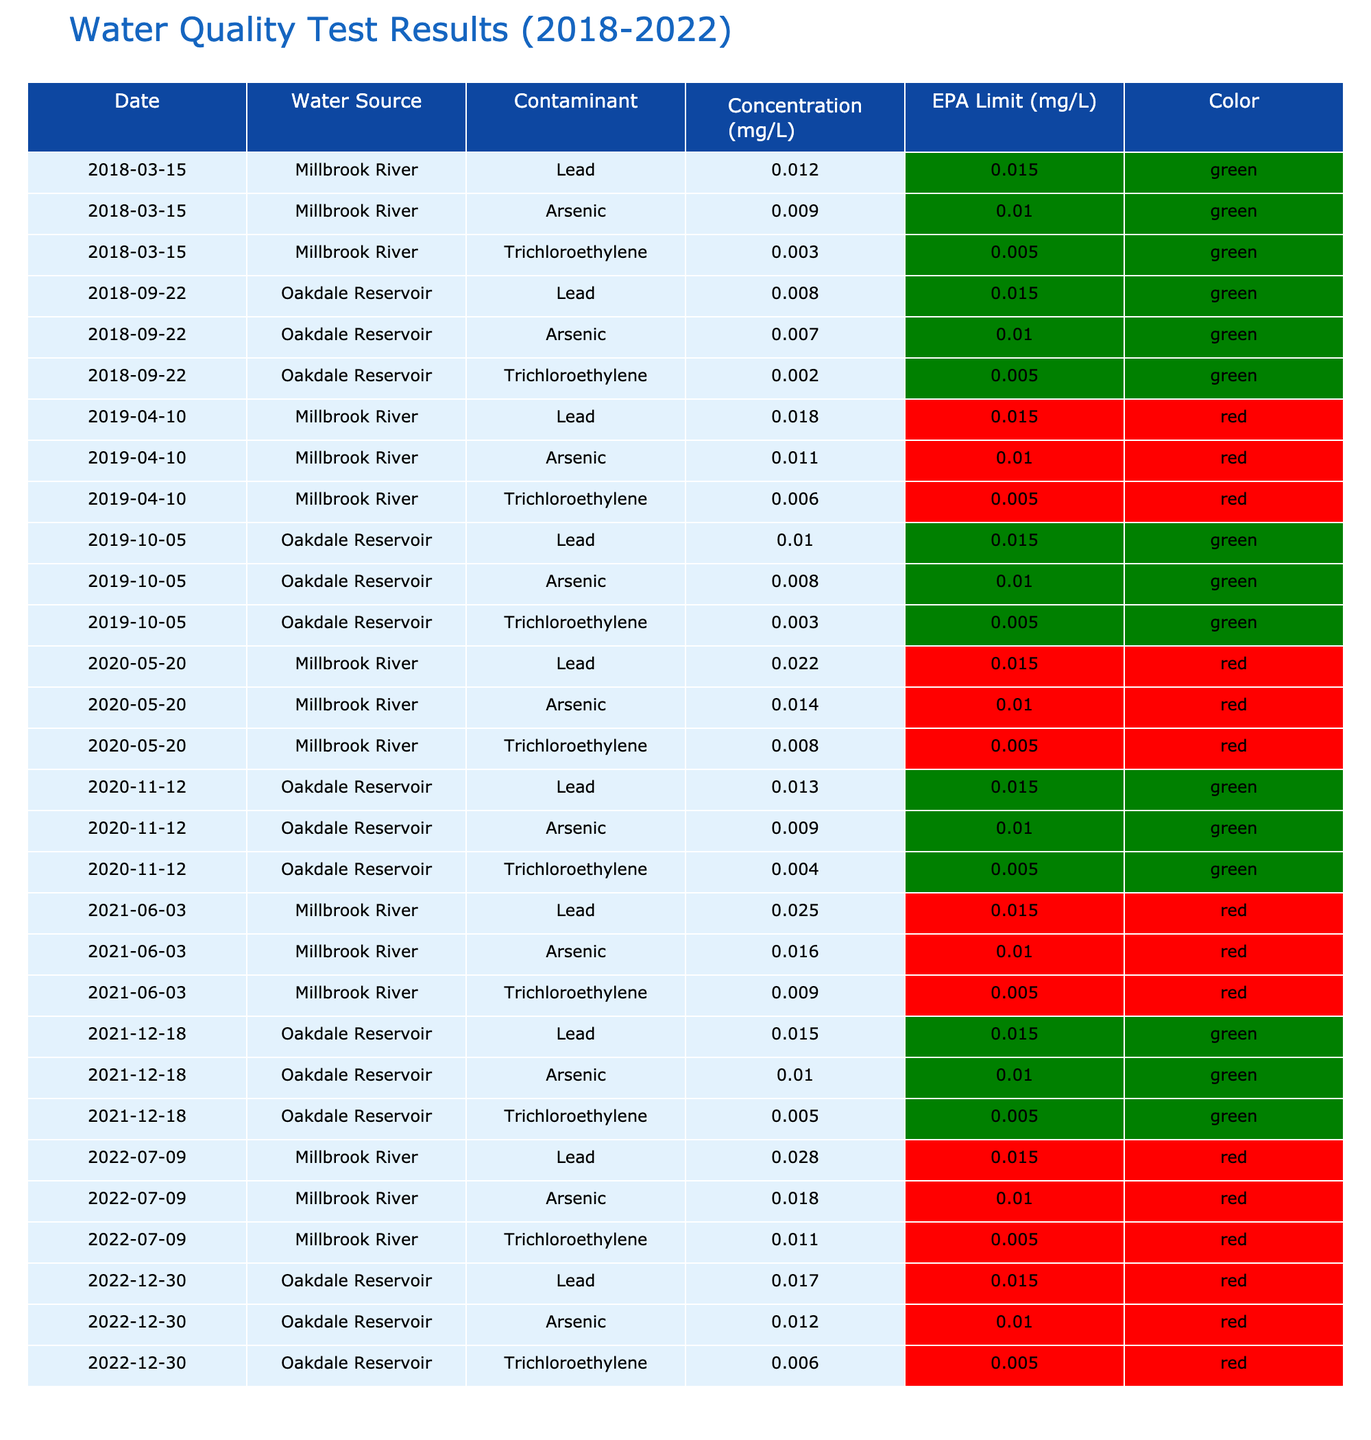What was the highest concentration of Lead reported in the Millbrook River? The table shows multiple entries for Lead in the Millbrook River. The highest concentration is 0.028 mg/L, which is listed on 2022-07-09.
Answer: 0.028 mg/L What was the concentration of Arsenic in the Oakdale Reservoir on 2020-11-12? According to the table, the concentration of Arsenic in the Oakdale Reservoir on 2020-11-12 is 0.009 mg/L.
Answer: 0.009 mg/L How many times did the concentration of Trichloroethylene exceed the EPA limit in the Millbrook River? The entries for Trichloroethylene in the Millbrook River are 0.003, 0.006, 0.008, 0.009, and 0.011 mg/L, none of which exceed the EPA limit of 0.005 mg/L.
Answer: 0 times What is the average concentration of Lead in the Oakdale Reservoir from 2018 to 2022? The concentrations of Lead in the Oakdale Reservoir are 0.008, 0.010, 0.013, 0.015, and 0.017 mg/L. Adding these gives 0.073 mg/L. Dividing by the number of tests (5) gives an average of 0.0146 mg/L.
Answer: 0.0146 mg/L Did the concentration of Arsenic in the Millbrook River ever exceed the EPA limit in the years tested? The concentrations of Arsenic in the Millbrook River were 0.009, 0.011, 0.014, 0.016, and 0.018 mg/L compared to the EPA limit of 0.010 mg/L. The concentrations 0.014, 0.016, and 0.018 exceed the limit, confirming that it did exceed the EPA limit.
Answer: Yes What was the increase in concentration of Lead in the Millbrook River from 2018-03-15 to 2022-07-09? The concentration on 2018-03-15 was 0.012 mg/L and on 2022-07-09 it was 0.028 mg/L. The increase is 0.028 - 0.012 = 0.016 mg/L.
Answer: 0.016 mg/L Which water source had the highest maximum concentration of a single contaminant? Analyzing both rivers, the highest concentrations reported are 0.028 mg/L for Lead in the Millbrook River and 0.018 mg/L for Arsenic in the same river. Thus, the maximum is 0.028 mg/L from the Millbrook River.
Answer: Millbrook River Are there any contaminants in the Oakdale Reservoir that consistently meet the EPA limits based on the data? Evaluating the data, Arsenic and Trichloroethylene concentrations in the Oakdale Reservoir never exceed the EPA limits across all dates. Hence, yes, certain contaminants consistently meet the limits.
Answer: Yes 